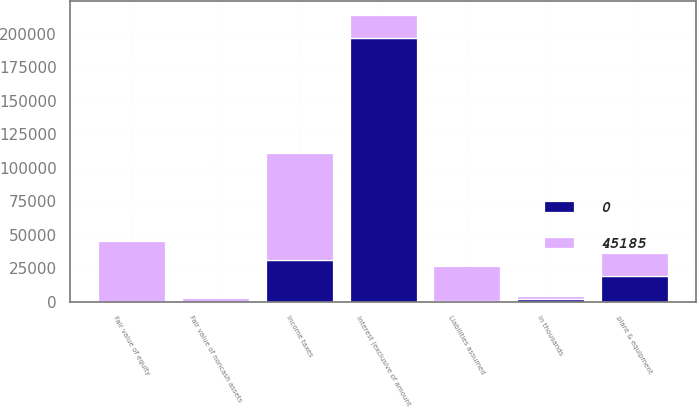<chart> <loc_0><loc_0><loc_500><loc_500><stacked_bar_chart><ecel><fcel>in thousands<fcel>Interest (exclusive of amount<fcel>Income taxes<fcel>plant & equipment<fcel>Liabilities assumed<fcel>Fair value of noncash assets<fcel>Fair value of equity<nl><fcel>45185<fcel>2014<fcel>17120<fcel>79862<fcel>17120<fcel>26622<fcel>2414<fcel>45185<nl><fcel>0<fcel>2013<fcel>196794<fcel>30938<fcel>18864<fcel>232<fcel>0<fcel>0<nl></chart> 